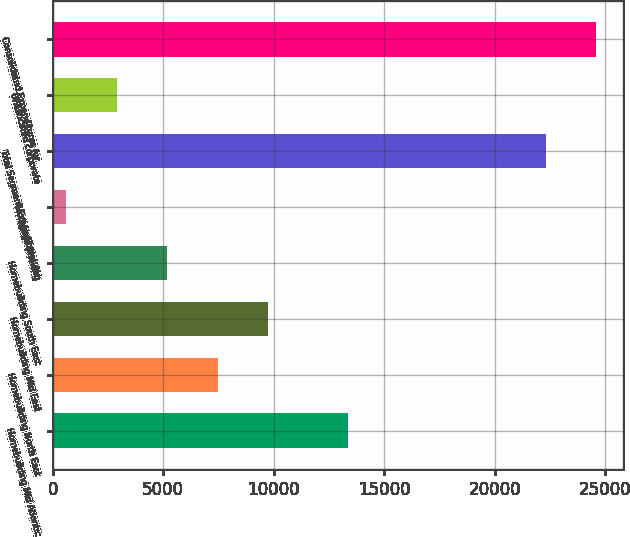Convert chart to OTSL. <chart><loc_0><loc_0><loc_500><loc_500><bar_chart><fcel>Homebuilding Mid Atlantic<fcel>Homebuilding North East<fcel>Homebuilding Mid East<fcel>Homebuilding South East<fcel>Mortgage Banking<fcel>Total Segment Expenditures for<fcel>Unallocated corporate<fcel>Consolidated Expenditures for<nl><fcel>13355<fcel>7457.7<fcel>9739.6<fcel>5175.8<fcel>612<fcel>22306<fcel>2893.9<fcel>24587.9<nl></chart> 